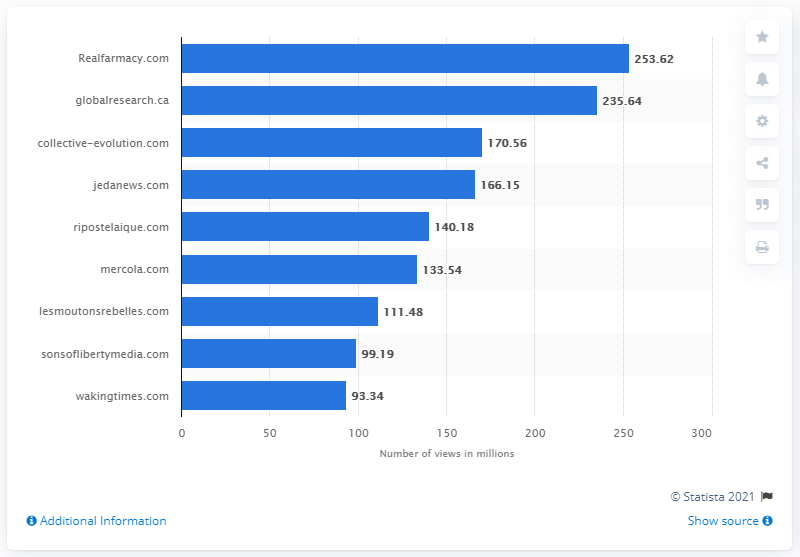Specify some key components in this picture. The website with the least views in the chart is wakingtimes.com. During the period from May 2019 to May 2020, Realfarmacy.com had a total of 253.62 views. There are six websites in the charts that have over 120 million views. 